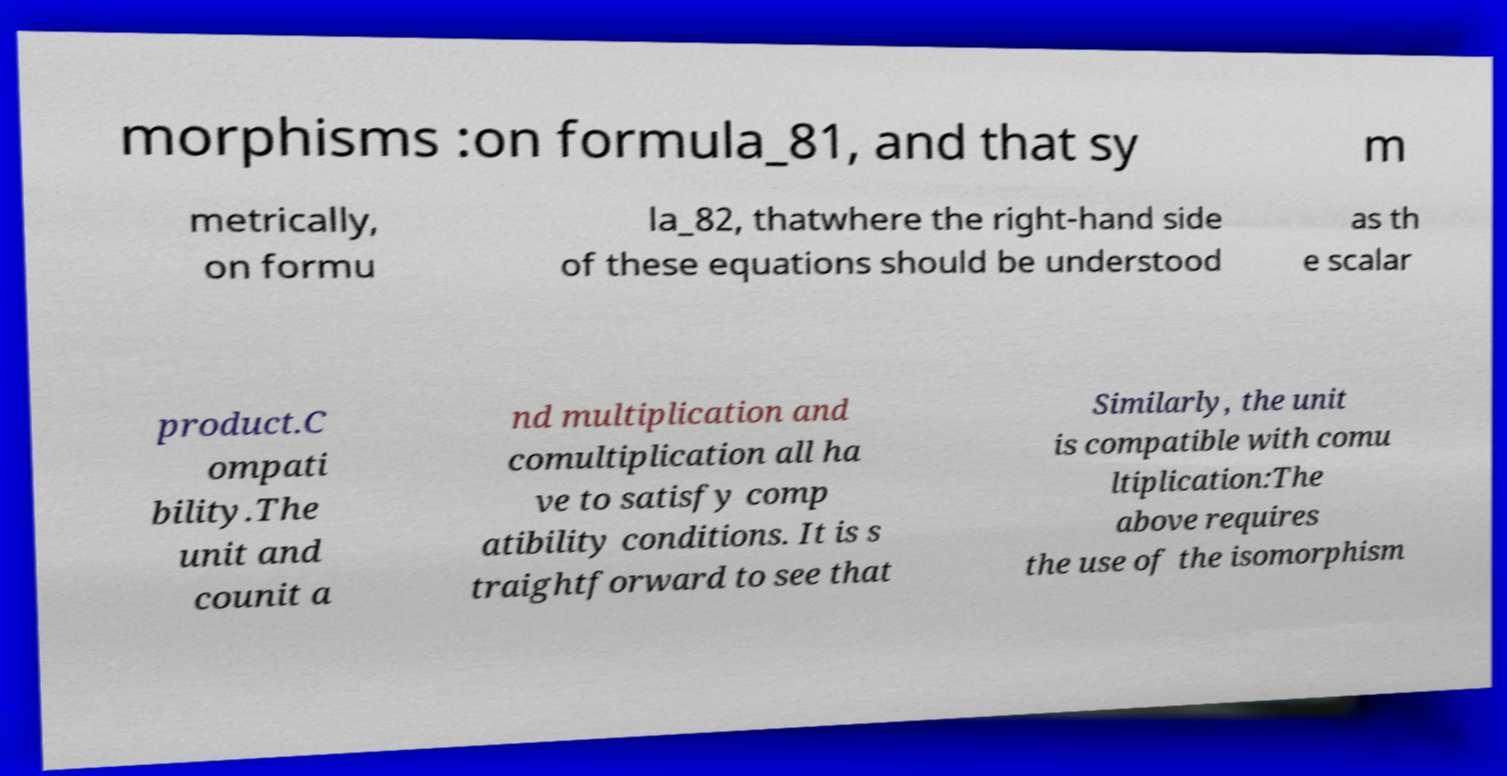Please identify and transcribe the text found in this image. morphisms :on formula_81, and that sy m metrically, on formu la_82, thatwhere the right-hand side of these equations should be understood as th e scalar product.C ompati bility.The unit and counit a nd multiplication and comultiplication all ha ve to satisfy comp atibility conditions. It is s traightforward to see that Similarly, the unit is compatible with comu ltiplication:The above requires the use of the isomorphism 